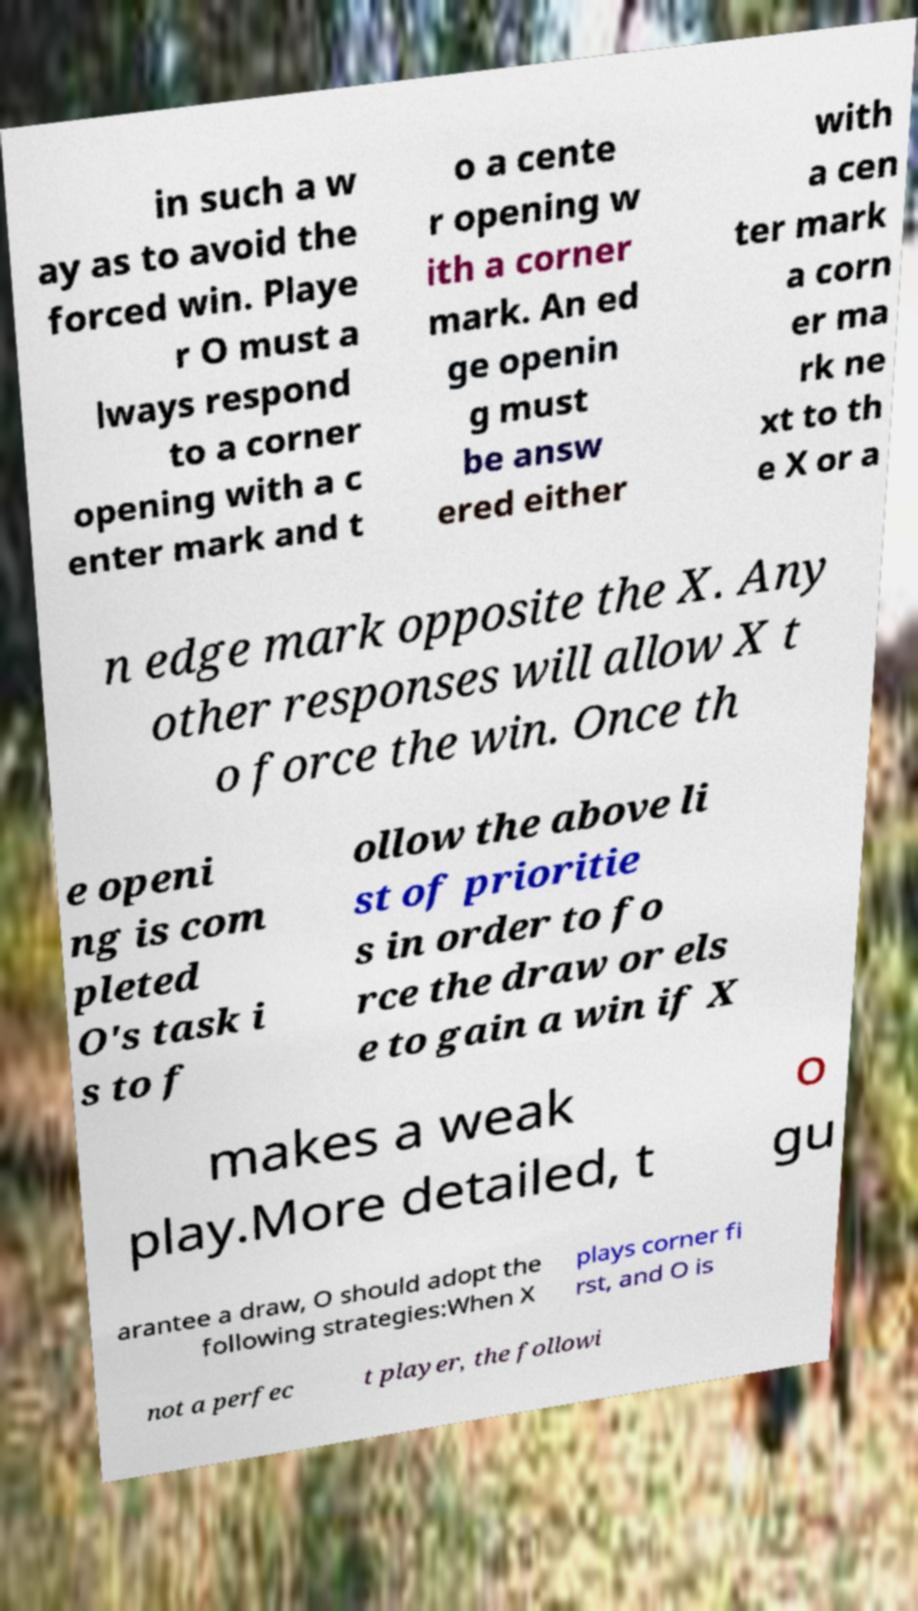Could you extract and type out the text from this image? in such a w ay as to avoid the forced win. Playe r O must a lways respond to a corner opening with a c enter mark and t o a cente r opening w ith a corner mark. An ed ge openin g must be answ ered either with a cen ter mark a corn er ma rk ne xt to th e X or a n edge mark opposite the X. Any other responses will allow X t o force the win. Once th e openi ng is com pleted O's task i s to f ollow the above li st of prioritie s in order to fo rce the draw or els e to gain a win if X makes a weak play.More detailed, t o gu arantee a draw, O should adopt the following strategies:When X plays corner fi rst, and O is not a perfec t player, the followi 